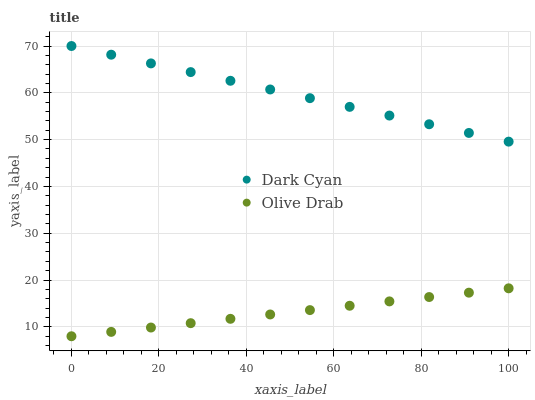Does Olive Drab have the minimum area under the curve?
Answer yes or no. Yes. Does Dark Cyan have the maximum area under the curve?
Answer yes or no. Yes. Does Olive Drab have the maximum area under the curve?
Answer yes or no. No. Is Olive Drab the smoothest?
Answer yes or no. Yes. Is Dark Cyan the roughest?
Answer yes or no. Yes. Is Olive Drab the roughest?
Answer yes or no. No. Does Olive Drab have the lowest value?
Answer yes or no. Yes. Does Dark Cyan have the highest value?
Answer yes or no. Yes. Does Olive Drab have the highest value?
Answer yes or no. No. Is Olive Drab less than Dark Cyan?
Answer yes or no. Yes. Is Dark Cyan greater than Olive Drab?
Answer yes or no. Yes. Does Olive Drab intersect Dark Cyan?
Answer yes or no. No. 